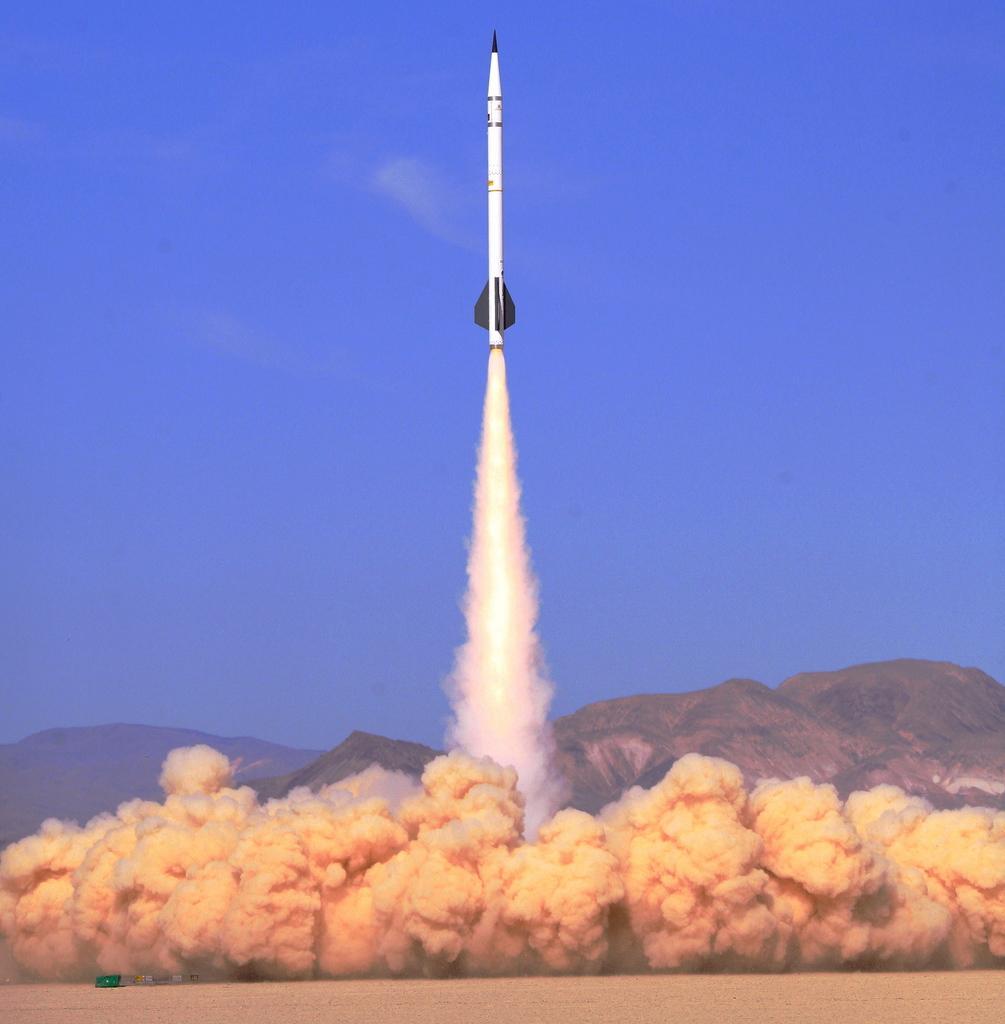Could you give a brief overview of what you see in this image? In this picture i can see a rocket which is flying and also i can a lot of smoke and also i can see a mountain. 